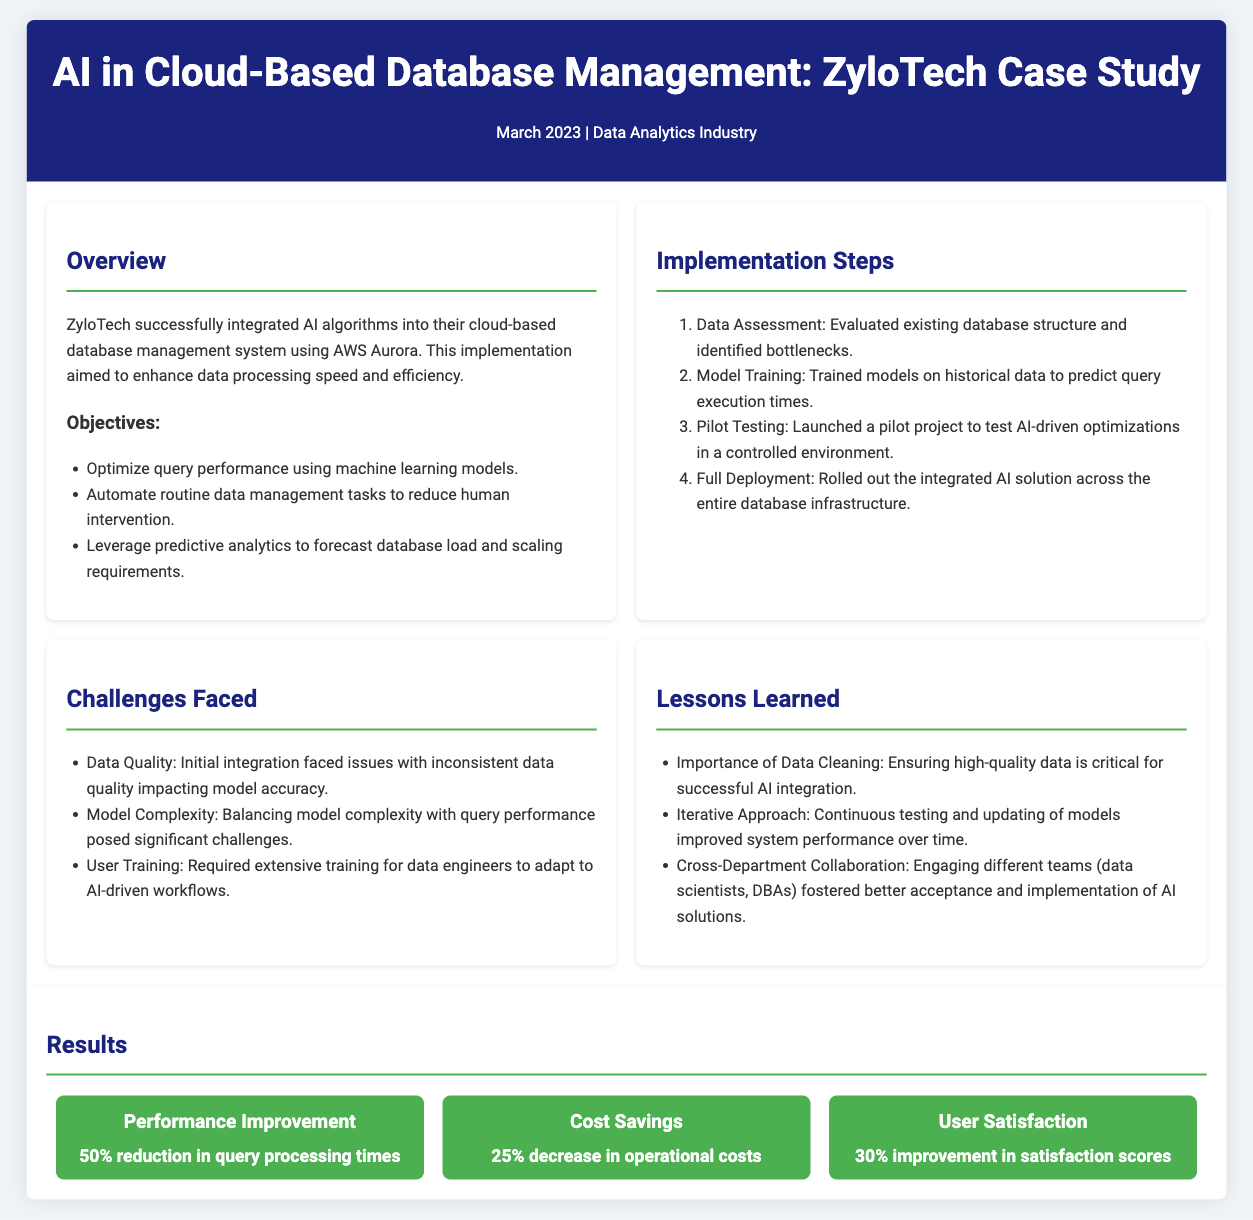what is the title of the case study? The title of the case study is provided in the header of the document.
Answer: AI in Cloud-Based Database Management: ZyloTech Case Study what month and year was the case study published? The publication date is mentioned right below the title.
Answer: March 2023 what platform was used for the AI implementation? The document states that ZyloTech used a specific cloud service for their implementation.
Answer: AWS Aurora how much was the reduction in query processing times? The results section details the performance improvement achieved.
Answer: 50% what percentage of operational costs was saved? The document lists the cost savings achieved through the AI implementation.
Answer: 25% what was a challenge regarding data quality? The challenges section identifies an issue that impacted model accuracy during integration.
Answer: Inconsistent data quality what lesson was learned about data cleaning? The lessons learned section emphasizes a critical point regarding AI integration.
Answer: Ensuring high-quality data is critical what was one of the objectives of the implementation? The objectives section outlines the goals set by ZyloTech for their AI integration.
Answer: Optimize query performance using machine learning models how did user satisfaction improve post-implementation? The improvements are quantified in the results section of the document.
Answer: 30% improvement in satisfaction scores 